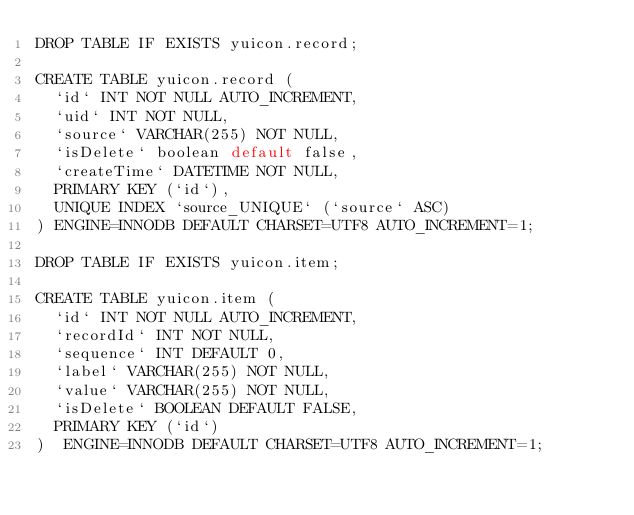<code> <loc_0><loc_0><loc_500><loc_500><_SQL_>DROP TABLE IF EXISTS yuicon.record;

CREATE TABLE yuicon.record (
  `id` INT NOT NULL AUTO_INCREMENT,
  `uid` INT NOT NULL,
  `source` VARCHAR(255) NOT NULL,
  `isDelete` boolean default false,
  `createTime` DATETIME NOT NULL,
  PRIMARY KEY (`id`),
  UNIQUE INDEX `source_UNIQUE` (`source` ASC)
) ENGINE=INNODB DEFAULT CHARSET=UTF8 AUTO_INCREMENT=1;

DROP TABLE IF EXISTS yuicon.item;

CREATE TABLE yuicon.item (
  `id` INT NOT NULL AUTO_INCREMENT,
  `recordId` INT NOT NULL,
  `sequence` INT DEFAULT 0,
  `label` VARCHAR(255) NOT NULL,
  `value` VARCHAR(255) NOT NULL,
  `isDelete` BOOLEAN DEFAULT FALSE,
  PRIMARY KEY (`id`)
)  ENGINE=INNODB DEFAULT CHARSET=UTF8 AUTO_INCREMENT=1;
</code> 